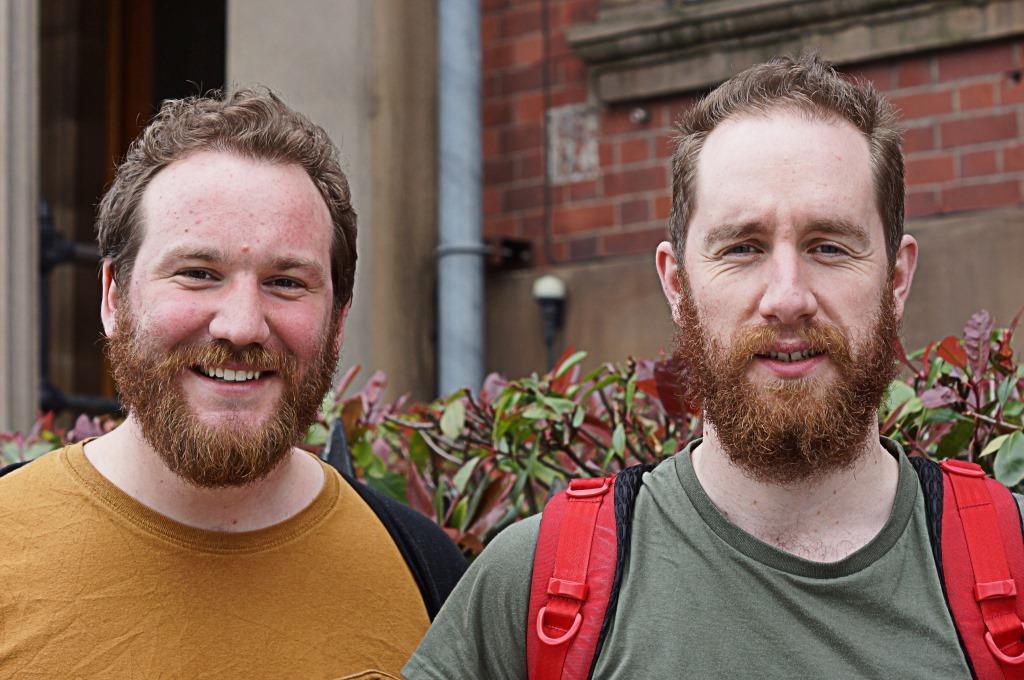How would you summarize this image in a sentence or two? This picture is clicked outside. In the foreground we can see the two men wearing t-shirts and backpacks and seems to be standing. In the background we can see the plants, building, metal rod and the wall of a building. 